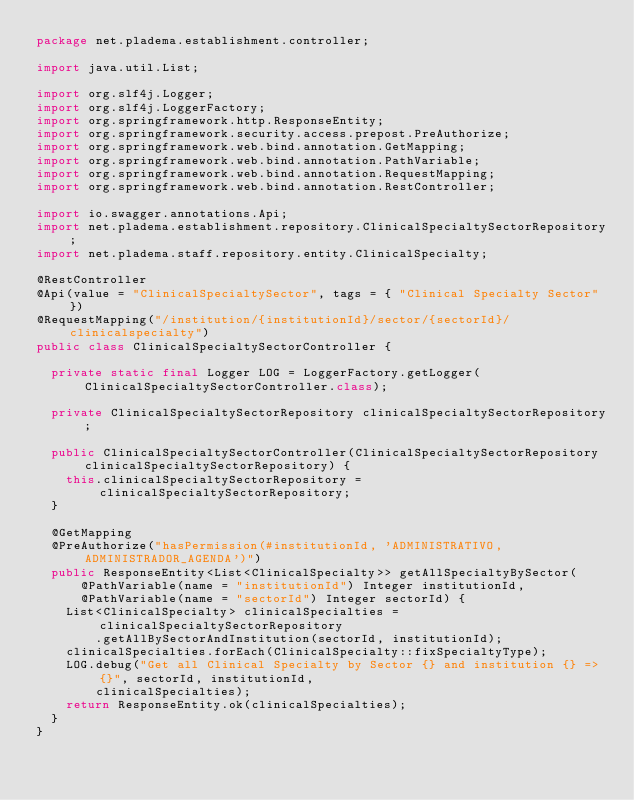Convert code to text. <code><loc_0><loc_0><loc_500><loc_500><_Java_>package net.pladema.establishment.controller;

import java.util.List;

import org.slf4j.Logger;
import org.slf4j.LoggerFactory;
import org.springframework.http.ResponseEntity;
import org.springframework.security.access.prepost.PreAuthorize;
import org.springframework.web.bind.annotation.GetMapping;
import org.springframework.web.bind.annotation.PathVariable;
import org.springframework.web.bind.annotation.RequestMapping;
import org.springframework.web.bind.annotation.RestController;

import io.swagger.annotations.Api;
import net.pladema.establishment.repository.ClinicalSpecialtySectorRepository;
import net.pladema.staff.repository.entity.ClinicalSpecialty;

@RestController
@Api(value = "ClinicalSpecialtySector", tags = { "Clinical Specialty Sector" })
@RequestMapping("/institution/{institutionId}/sector/{sectorId}/clinicalspecialty")
public class ClinicalSpecialtySectorController {

	private static final Logger LOG = LoggerFactory.getLogger(ClinicalSpecialtySectorController.class);

	private ClinicalSpecialtySectorRepository clinicalSpecialtySectorRepository;

	public ClinicalSpecialtySectorController(ClinicalSpecialtySectorRepository clinicalSpecialtySectorRepository) {
		this.clinicalSpecialtySectorRepository = clinicalSpecialtySectorRepository;
	}

	@GetMapping
	@PreAuthorize("hasPermission(#institutionId, 'ADMINISTRATIVO, ADMINISTRADOR_AGENDA')")
	public ResponseEntity<List<ClinicalSpecialty>> getAllSpecialtyBySector(
			@PathVariable(name = "institutionId") Integer institutionId,
			@PathVariable(name = "sectorId") Integer sectorId) {
		List<ClinicalSpecialty> clinicalSpecialties = clinicalSpecialtySectorRepository
				.getAllBySectorAndInstitution(sectorId, institutionId);
		clinicalSpecialties.forEach(ClinicalSpecialty::fixSpecialtyType);
		LOG.debug("Get all Clinical Specialty by Sector {} and institution {} => {}", sectorId, institutionId,
				clinicalSpecialties);
		return ResponseEntity.ok(clinicalSpecialties);
	}
}
</code> 